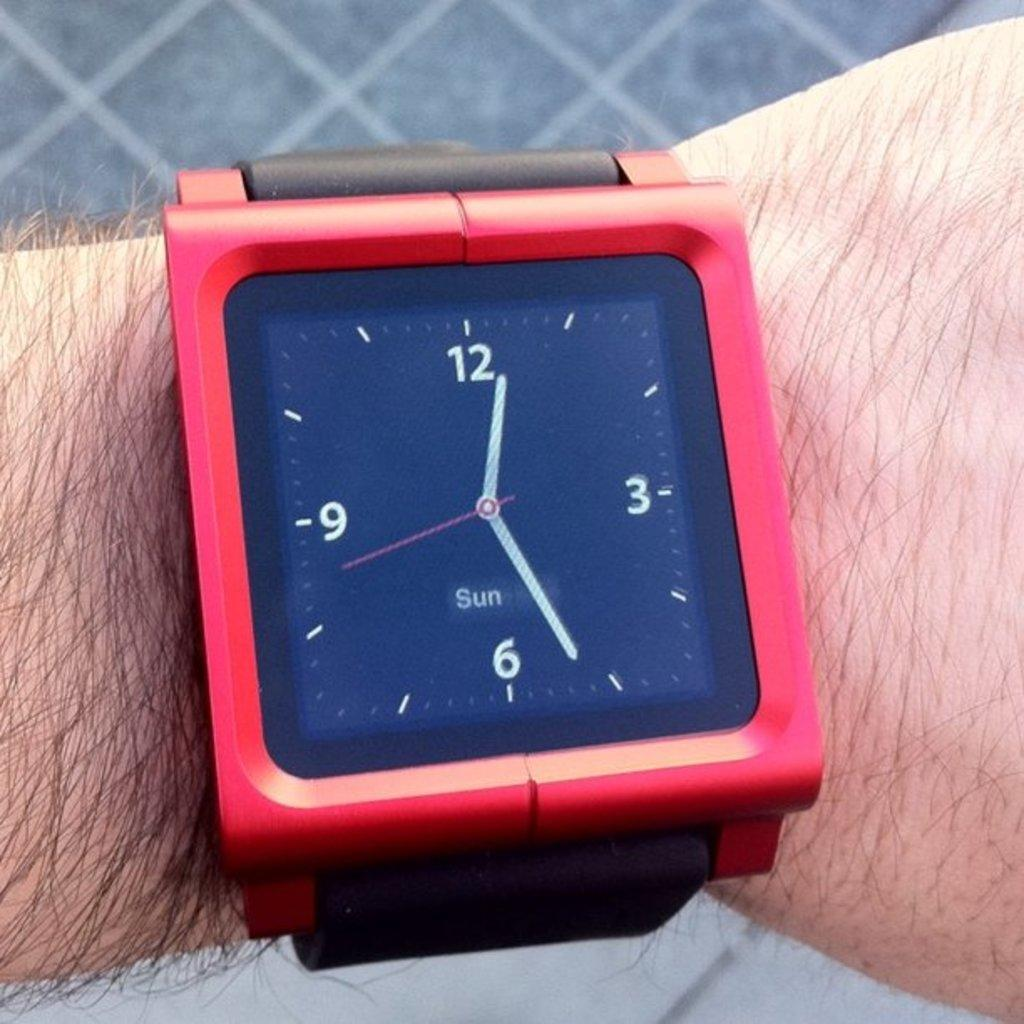Provide a one-sentence caption for the provided image. A small display on a wristwatch indicates that the day is Sunday. 